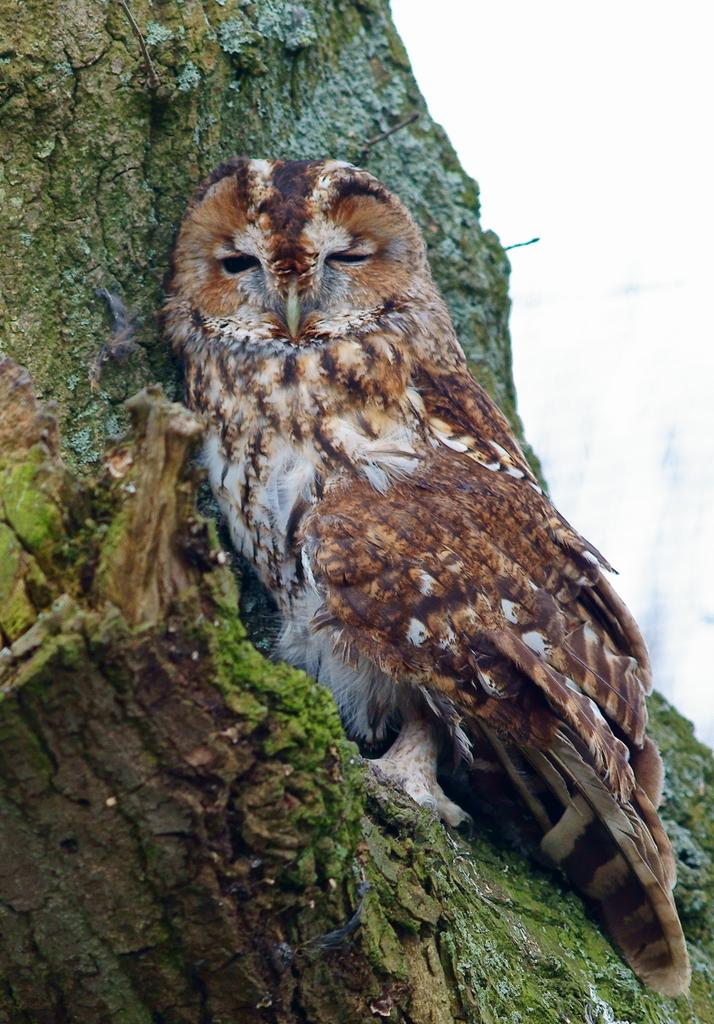What animal is present in the image? There is an owl in the image. Where is the owl located in the image? The owl is on the branch of a tree. What type of building can be seen in the image? There is no building present in the image; it features an owl on the branch of a tree. Who is the representative of the owl in the image? The image does not depict a representative of the owl; it simply shows an owl on a tree branch. 